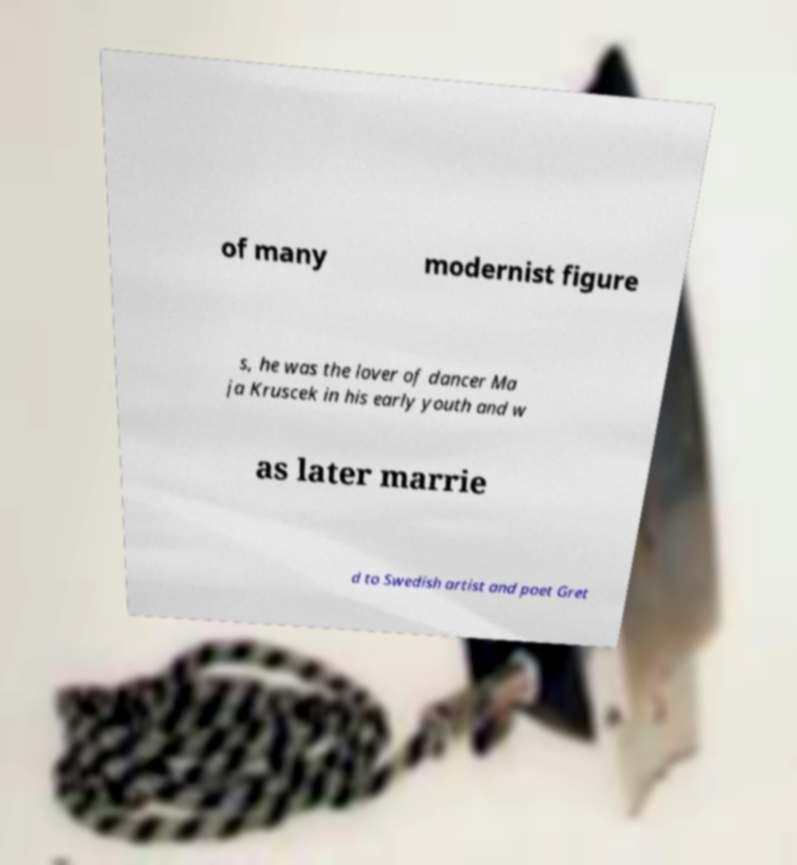Could you assist in decoding the text presented in this image and type it out clearly? of many modernist figure s, he was the lover of dancer Ma ja Kruscek in his early youth and w as later marrie d to Swedish artist and poet Gret 